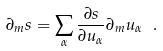<formula> <loc_0><loc_0><loc_500><loc_500>\partial _ { m } s = \sum _ { \alpha } \frac { \partial s } { \partial u _ { \alpha } } \partial _ { m } u _ { \alpha } \ .</formula> 